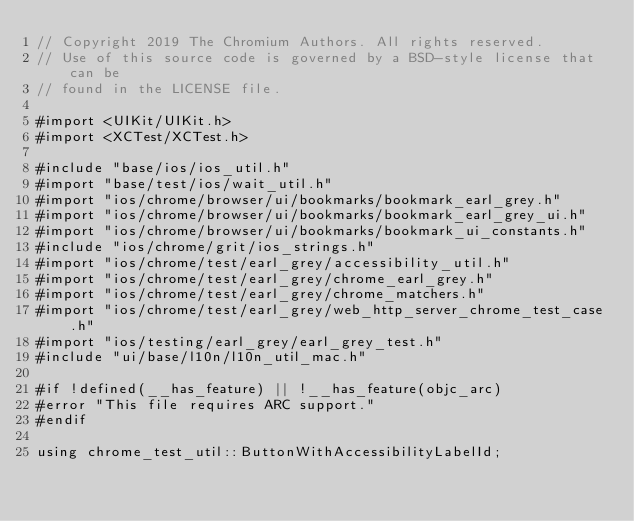<code> <loc_0><loc_0><loc_500><loc_500><_ObjectiveC_>// Copyright 2019 The Chromium Authors. All rights reserved.
// Use of this source code is governed by a BSD-style license that can be
// found in the LICENSE file.

#import <UIKit/UIKit.h>
#import <XCTest/XCTest.h>

#include "base/ios/ios_util.h"
#import "base/test/ios/wait_util.h"
#import "ios/chrome/browser/ui/bookmarks/bookmark_earl_grey.h"
#import "ios/chrome/browser/ui/bookmarks/bookmark_earl_grey_ui.h"
#import "ios/chrome/browser/ui/bookmarks/bookmark_ui_constants.h"
#include "ios/chrome/grit/ios_strings.h"
#import "ios/chrome/test/earl_grey/accessibility_util.h"
#import "ios/chrome/test/earl_grey/chrome_earl_grey.h"
#import "ios/chrome/test/earl_grey/chrome_matchers.h"
#import "ios/chrome/test/earl_grey/web_http_server_chrome_test_case.h"
#import "ios/testing/earl_grey/earl_grey_test.h"
#include "ui/base/l10n/l10n_util_mac.h"

#if !defined(__has_feature) || !__has_feature(objc_arc)
#error "This file requires ARC support."
#endif

using chrome_test_util::ButtonWithAccessibilityLabelId;</code> 